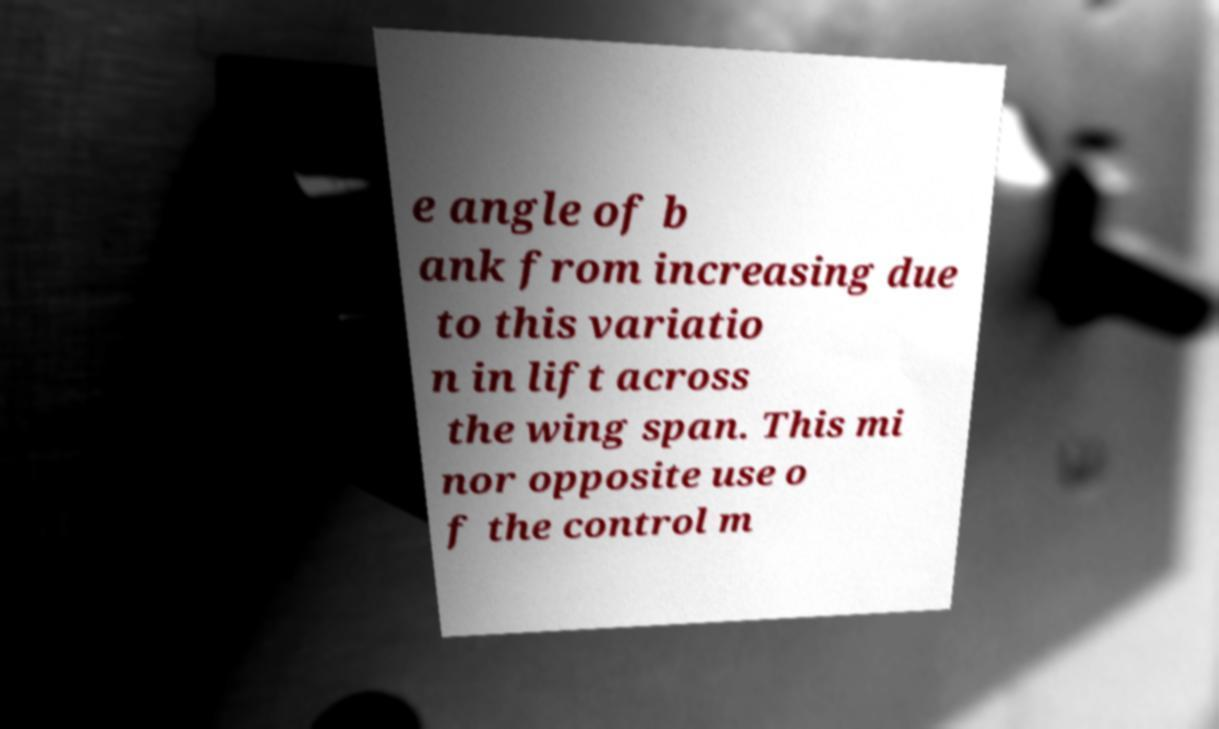Could you assist in decoding the text presented in this image and type it out clearly? e angle of b ank from increasing due to this variatio n in lift across the wing span. This mi nor opposite use o f the control m 